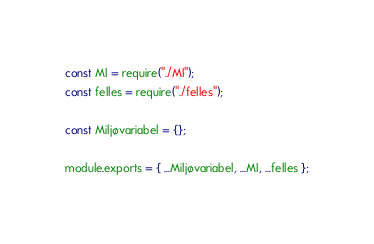Convert code to text. <code><loc_0><loc_0><loc_500><loc_500><_JavaScript_>const MI = require("./MI");
const felles = require("./felles");

const Miljøvariabel = {};

module.exports = { ...Miljøvariabel, ...MI, ...felles };
</code> 